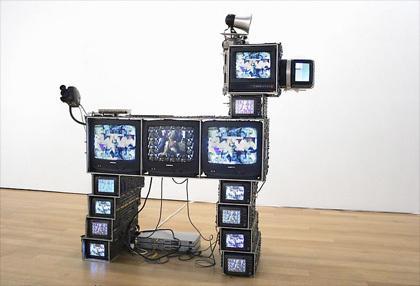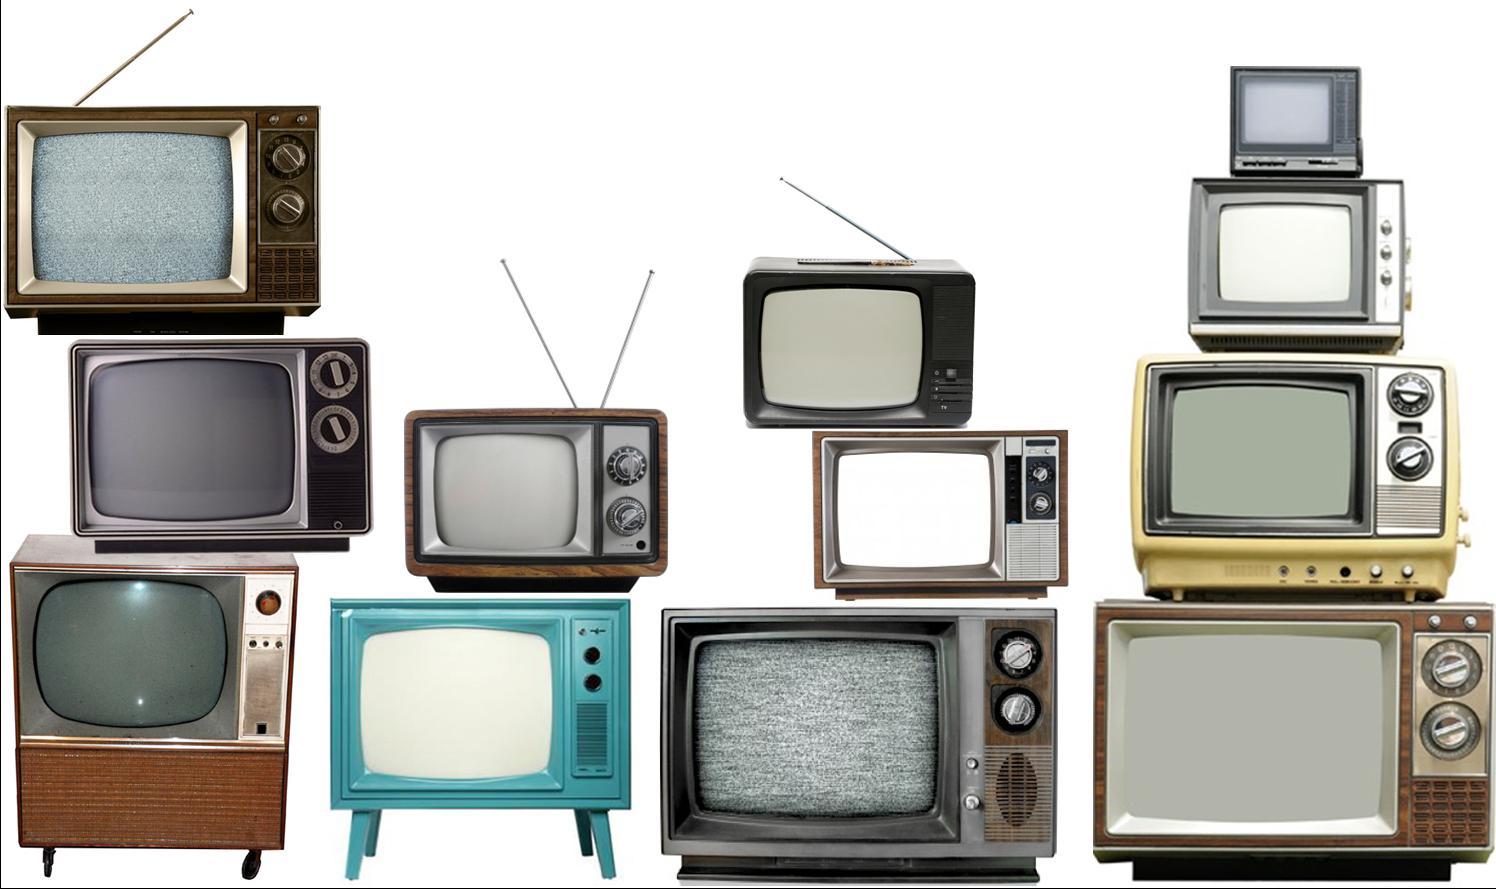The first image is the image on the left, the second image is the image on the right. Assess this claim about the two images: "Stacked cubes with screens take the shape of an animate object in one image.". Correct or not? Answer yes or no. Yes. The first image is the image on the left, the second image is the image on the right. Assess this claim about the two images: "A sculpture resembling a lifeform is made from televisions in one of the images.". Correct or not? Answer yes or no. Yes. 